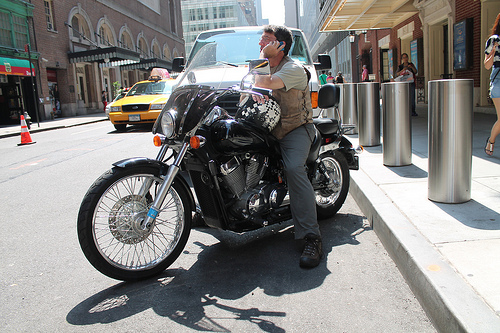Do you see any men to the left of the people on the side walk? Yes, there's a man standing beside the motorcycle, left of the people walking on the sidewalk. 